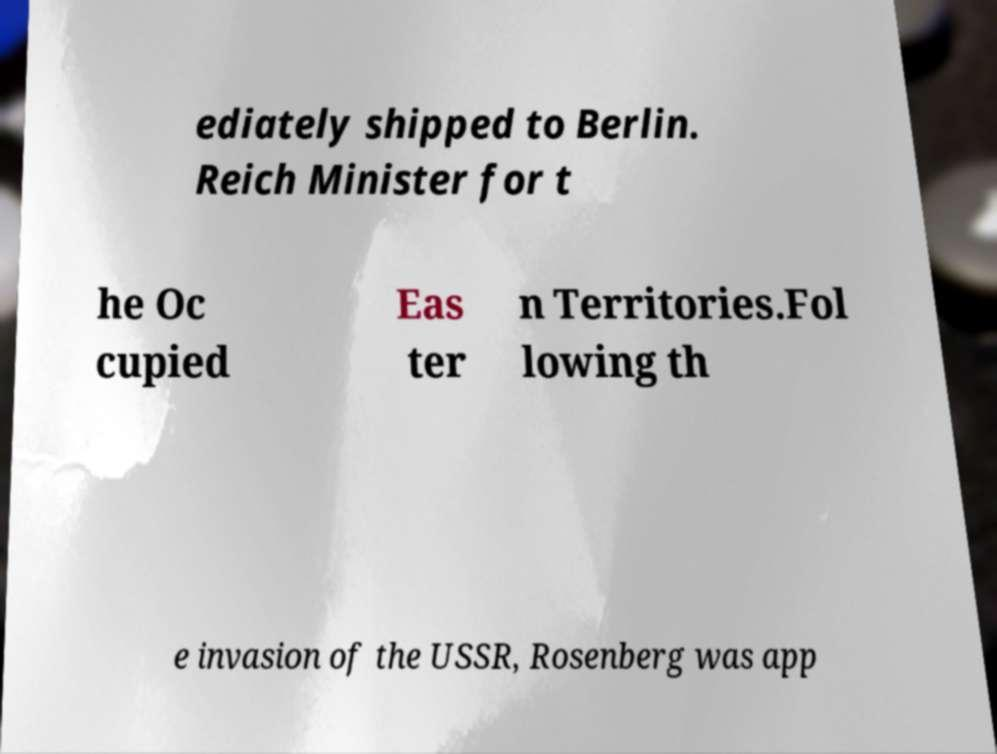There's text embedded in this image that I need extracted. Can you transcribe it verbatim? ediately shipped to Berlin. Reich Minister for t he Oc cupied Eas ter n Territories.Fol lowing th e invasion of the USSR, Rosenberg was app 